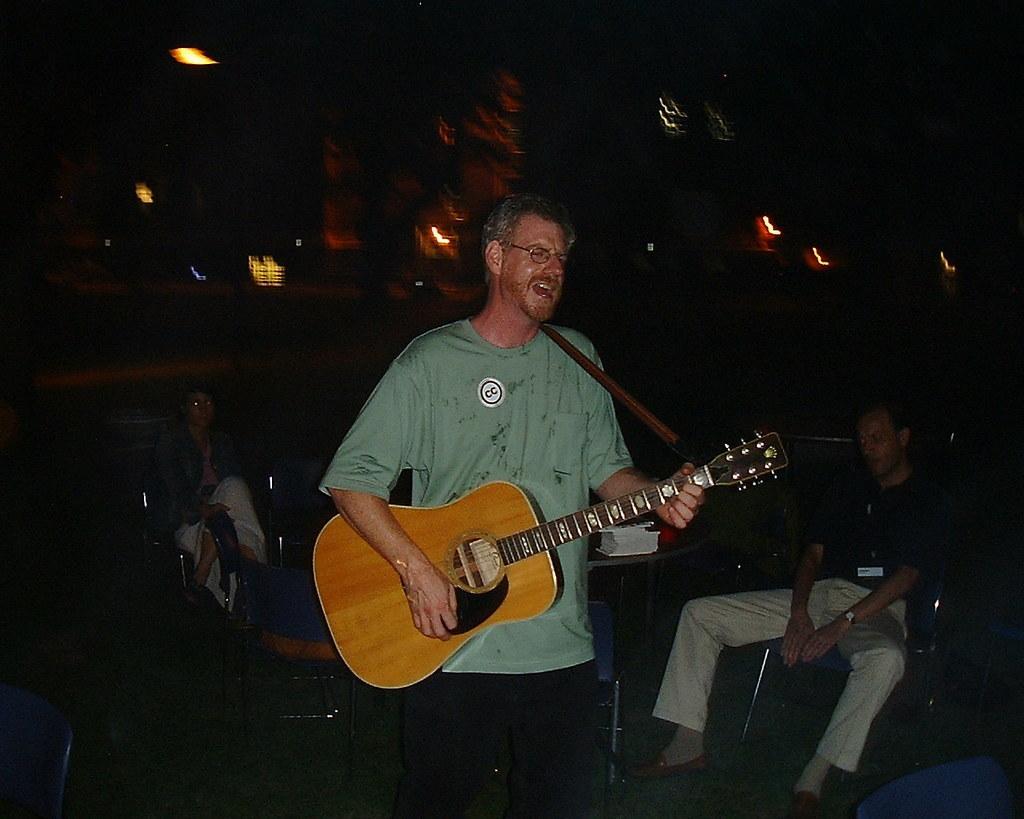How would you summarize this image in a sentence or two? In this image, In the middle there is a man standing and he is holding a music instrument which is in yellow color he is singing, In the background there are some people sitting on the chairs. 